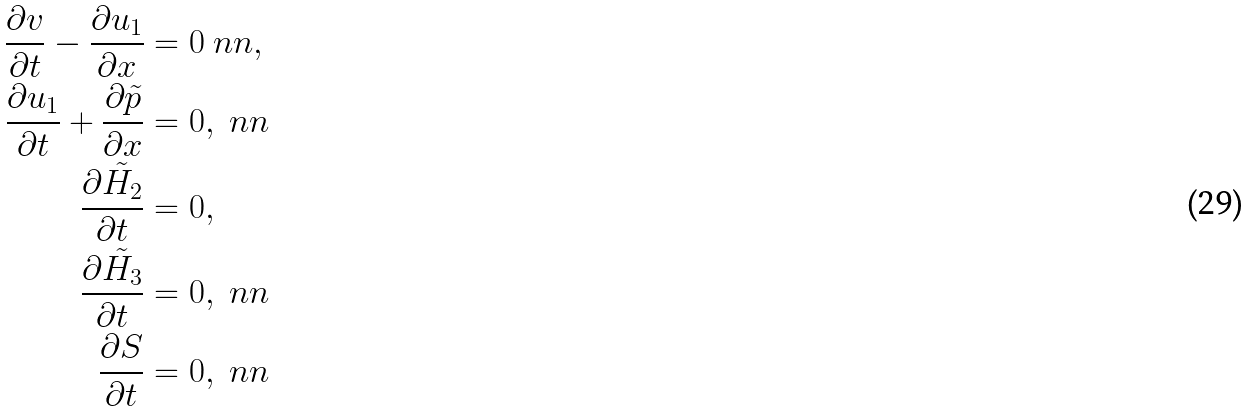<formula> <loc_0><loc_0><loc_500><loc_500>\frac { \partial v } { \partial t } - \frac { \partial u _ { 1 } } { \partial x } & = 0 \ n n , \\ \frac { \partial u _ { 1 } } { \partial t } + \frac { \partial \tilde { p } } { \partial x } & = 0 , \ n n \\ \frac { \partial \tilde { H _ { 2 } } } { \partial t } & = 0 , \\ \frac { \partial \tilde { H _ { 3 } } } { \partial t } & = 0 , \ n n \\ \frac { \partial S } { \partial t } & = 0 , \ n n</formula> 